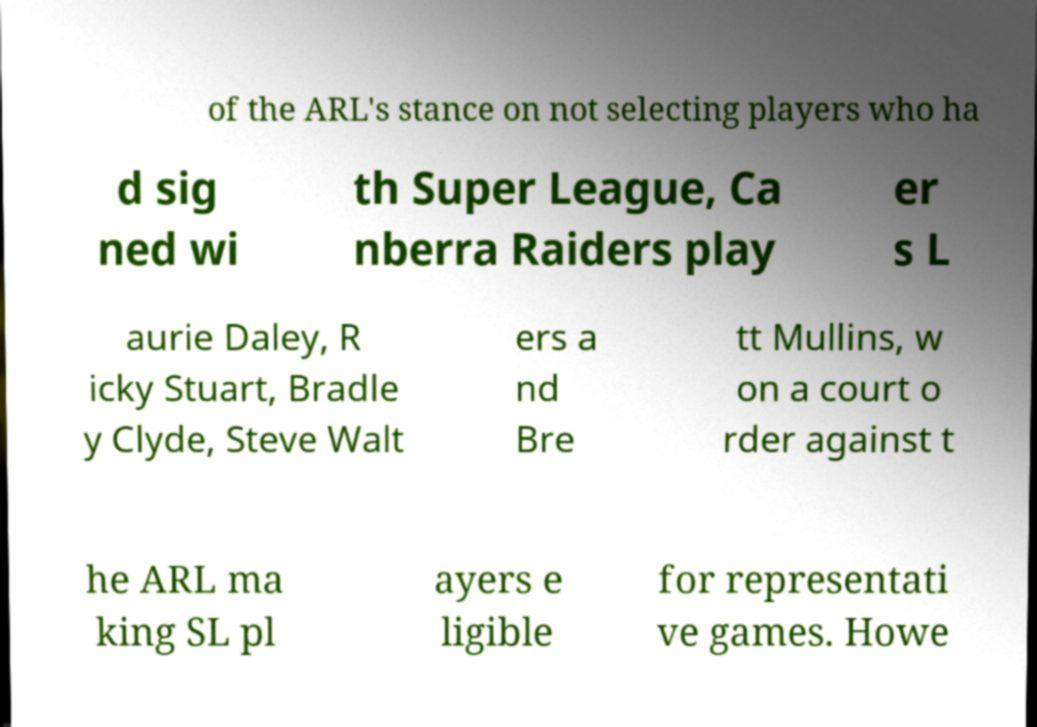Can you accurately transcribe the text from the provided image for me? of the ARL's stance on not selecting players who ha d sig ned wi th Super League, Ca nberra Raiders play er s L aurie Daley, R icky Stuart, Bradle y Clyde, Steve Walt ers a nd Bre tt Mullins, w on a court o rder against t he ARL ma king SL pl ayers e ligible for representati ve games. Howe 